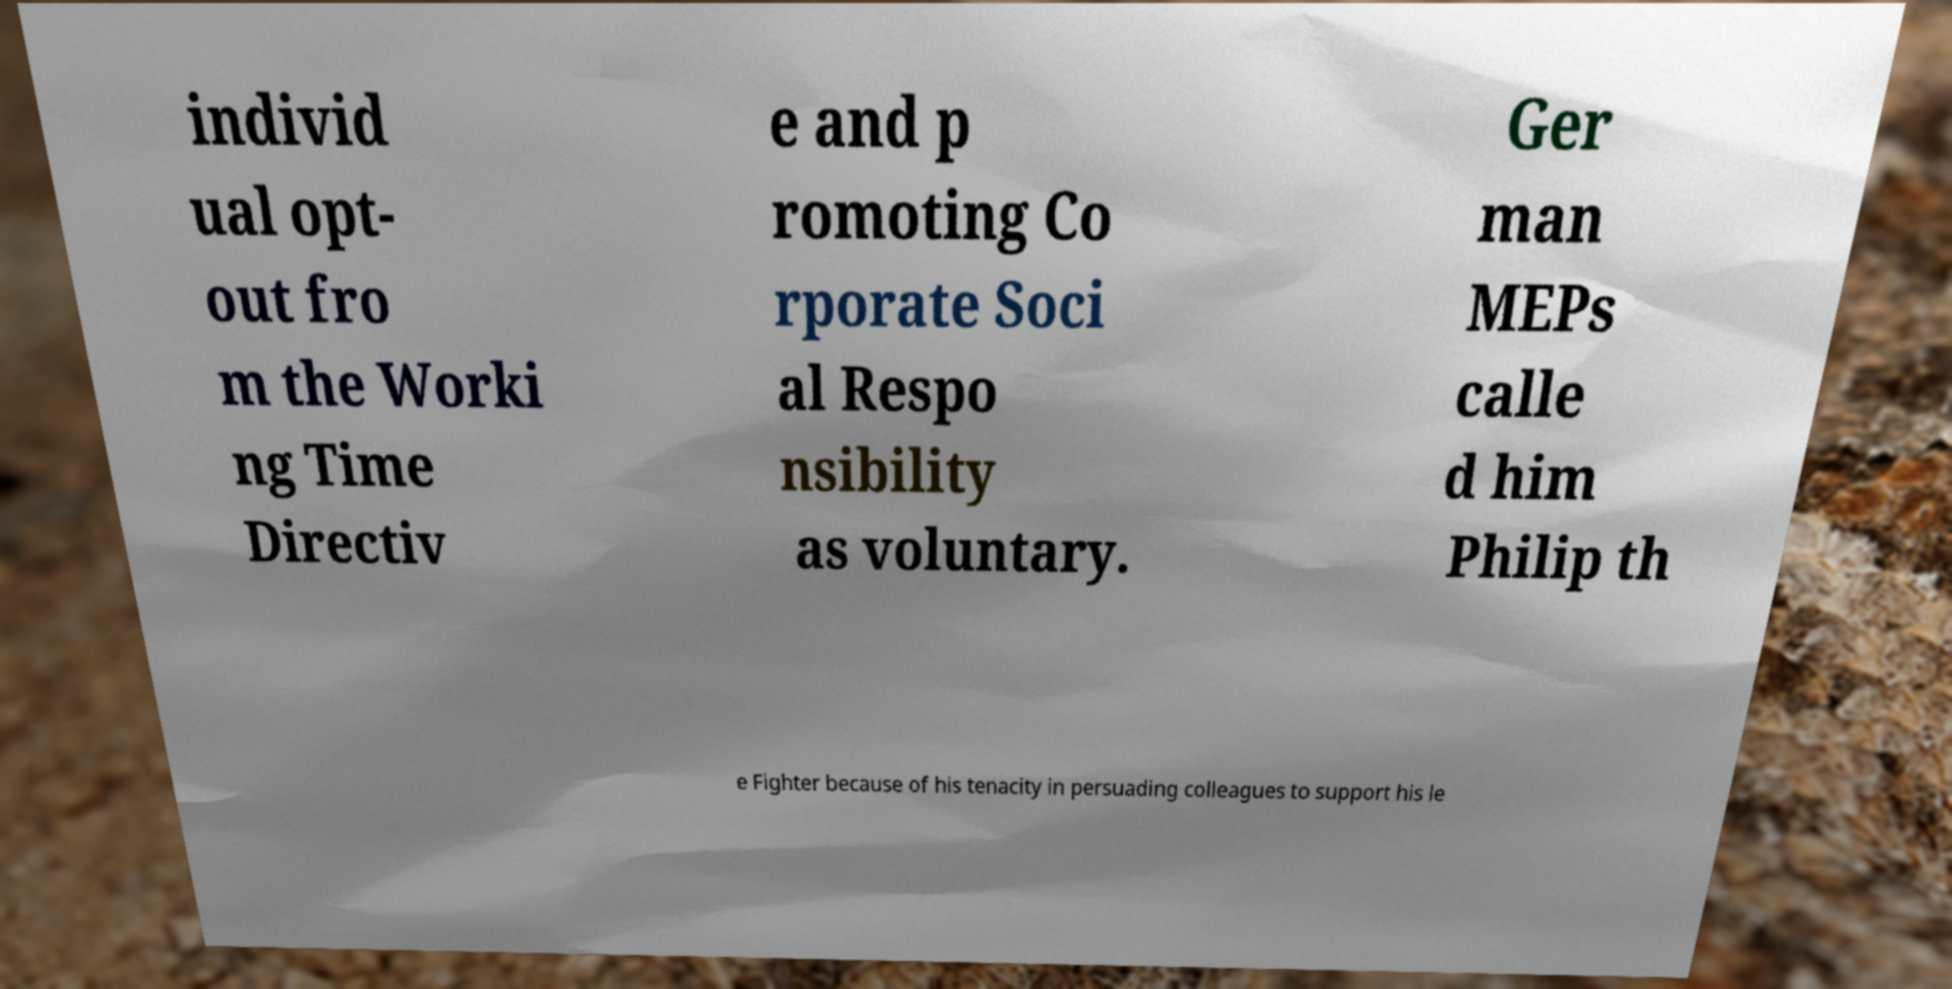Could you assist in decoding the text presented in this image and type it out clearly? individ ual opt- out fro m the Worki ng Time Directiv e and p romoting Co rporate Soci al Respo nsibility as voluntary. Ger man MEPs calle d him Philip th e Fighter because of his tenacity in persuading colleagues to support his le 